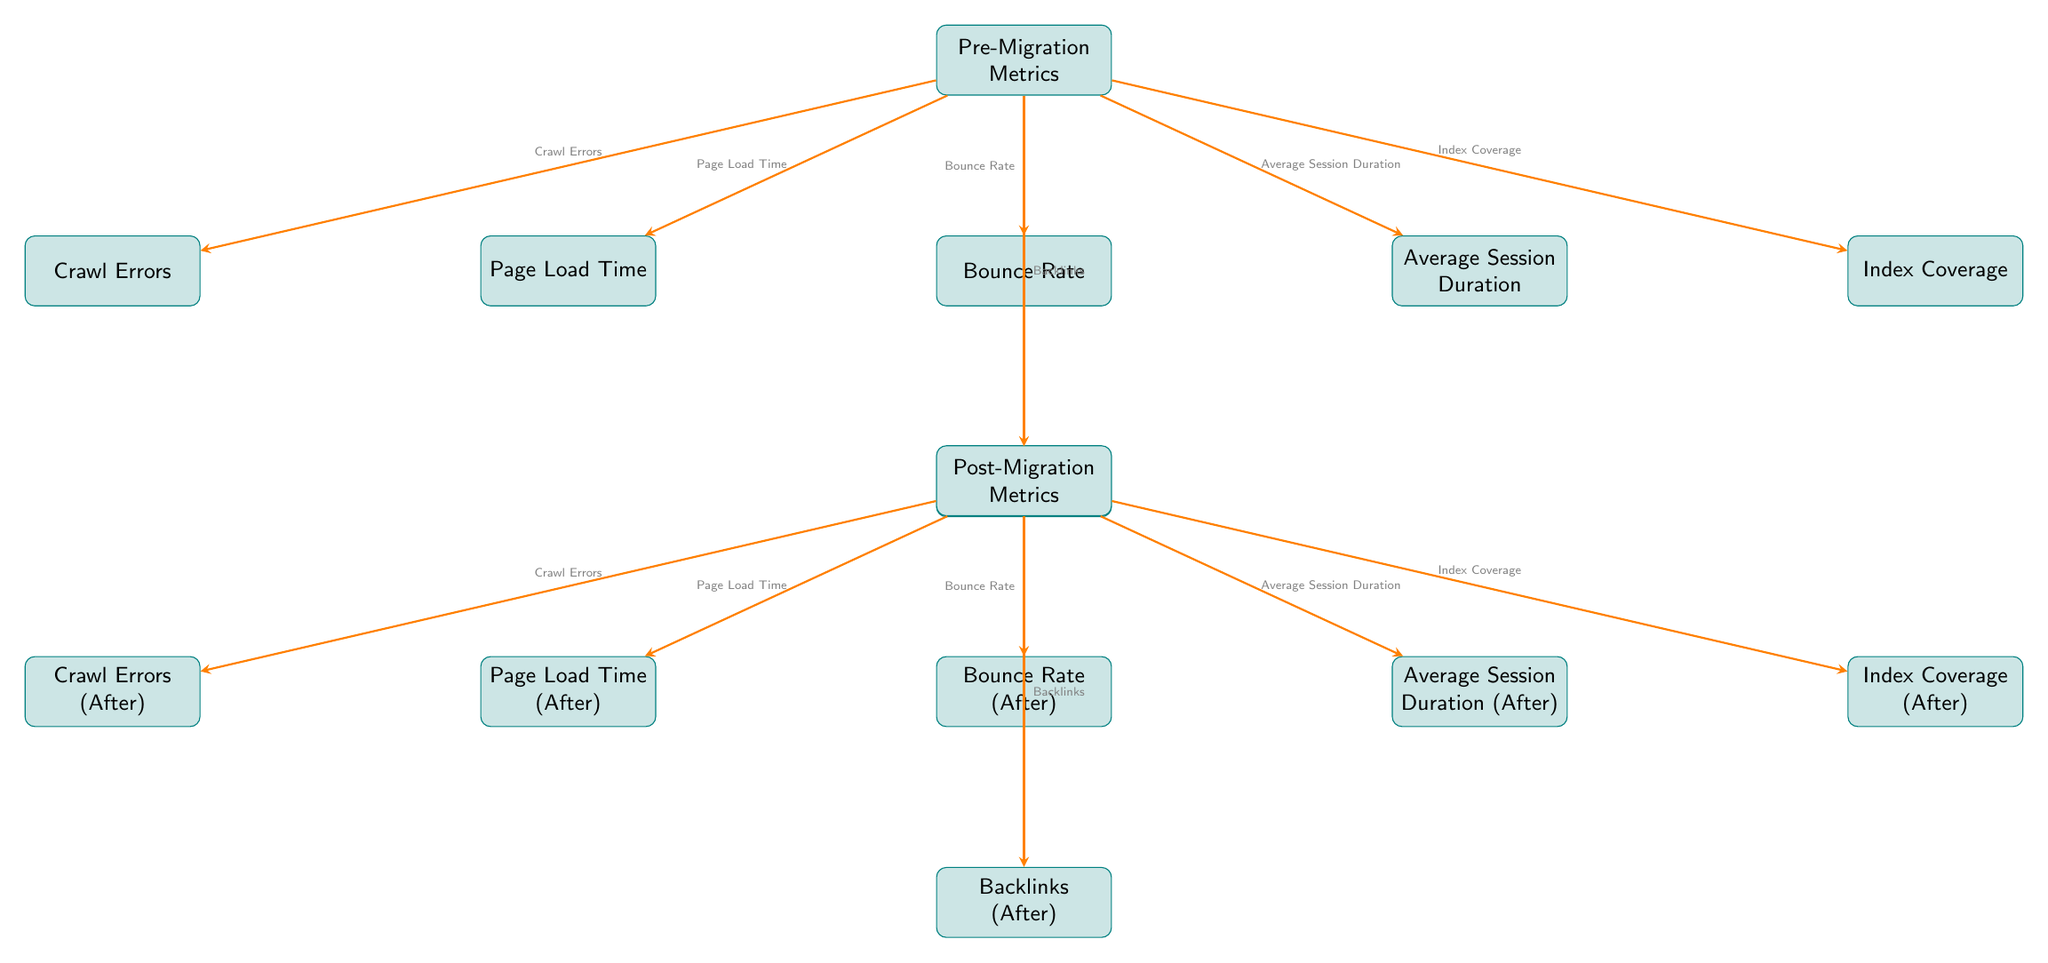What metrics are shown in the Pre-Migration section? The Pre-Migration section contains five metrics: Page Load Time, Bounce Rate, Average Session Duration, Crawl Errors, and Index Coverage. These metrics are directly listed in rectangular boxes beneath the "Pre-Migration Metrics" node.
Answer: Page Load Time, Bounce Rate, Average Session Duration, Crawl Errors, Index Coverage How many metrics are listed in the Post-Migration section? Similar to the Pre-Migration section, the Post-Migration section includes five metrics: Page Load Time (After), Bounce Rate (After), Average Session Duration (After), Crawl Errors (After), and Index Coverage (After). This count is obtained by counting the nodes under "Post-Migration Metrics."
Answer: Five What is the first metric under Post-Migration? The first metric listed directly beneath the "Post-Migration Metrics" node is "Page Load Time (After)." This metric appears first in the arrangement, signified by its position under the main node.
Answer: Page Load Time (After) What denotes the relationship between Crawl Errors and Index Coverage in the Pre-Migration section? The diagram indicates an upward relationship where both metrics are influenced by the Pre-Migration Metrics node. Crawl Errors and Index Coverage are positioned toward the left and right, respectively, but share the main node as their source.
Answer: Influenced by Pre-Migration Metrics After migrating to Jekyll, what is a likely change in Crawl Errors? In the Post-Migration section, the metric "Crawl Errors (After)" is included, indicating that there is a focused measurement of crawl errors following the migration. A reasonable inference is that the number of crawl errors could decrease after migration, although the exact value isn't provided in the diagram.
Answer: Crawl Errors (After) What is the connection between Bounce Rate in Pre-Migration and Bounce Rate (After) in Post-Migration? Both are connected as they share the same basic metric of Bounce Rate, with the Post-Migration metric denoted by "Bounce Rate (After)." This implies a continuation of measuring the same performance aspect pre- and post-migration.
Answer: Same performance aspect What can be inferred about the relationship between Average Session Duration and Backlinks? Average Session Duration and Backlinks are both indicators of user engagement, but they do not have a direct path between them in the diagram. Instead, they are both influenced by the overarching Pre-Migration and Post-Migration nodes. This indicates that improvements in one could affect the other indirectly.
Answer: Indirect relationship What is unique about the labels attached to the arrows in the diagram? The labels attached to the arrows indicate the particular metrics that are being measured before and after migration, providing clarity on what each arrow signifies, thereby enhancing understanding of the relationship between metrics.
Answer: They indicate specific metrics 